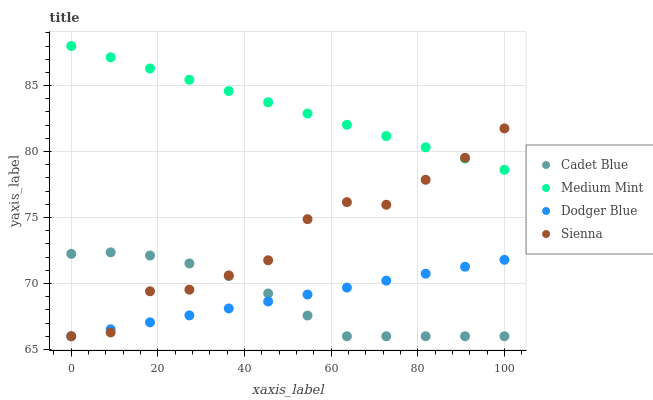Does Cadet Blue have the minimum area under the curve?
Answer yes or no. Yes. Does Medium Mint have the maximum area under the curve?
Answer yes or no. Yes. Does Sienna have the minimum area under the curve?
Answer yes or no. No. Does Sienna have the maximum area under the curve?
Answer yes or no. No. Is Dodger Blue the smoothest?
Answer yes or no. Yes. Is Sienna the roughest?
Answer yes or no. Yes. Is Cadet Blue the smoothest?
Answer yes or no. No. Is Cadet Blue the roughest?
Answer yes or no. No. Does Sienna have the lowest value?
Answer yes or no. Yes. Does Medium Mint have the highest value?
Answer yes or no. Yes. Does Sienna have the highest value?
Answer yes or no. No. Is Cadet Blue less than Medium Mint?
Answer yes or no. Yes. Is Medium Mint greater than Dodger Blue?
Answer yes or no. Yes. Does Dodger Blue intersect Sienna?
Answer yes or no. Yes. Is Dodger Blue less than Sienna?
Answer yes or no. No. Is Dodger Blue greater than Sienna?
Answer yes or no. No. Does Cadet Blue intersect Medium Mint?
Answer yes or no. No. 